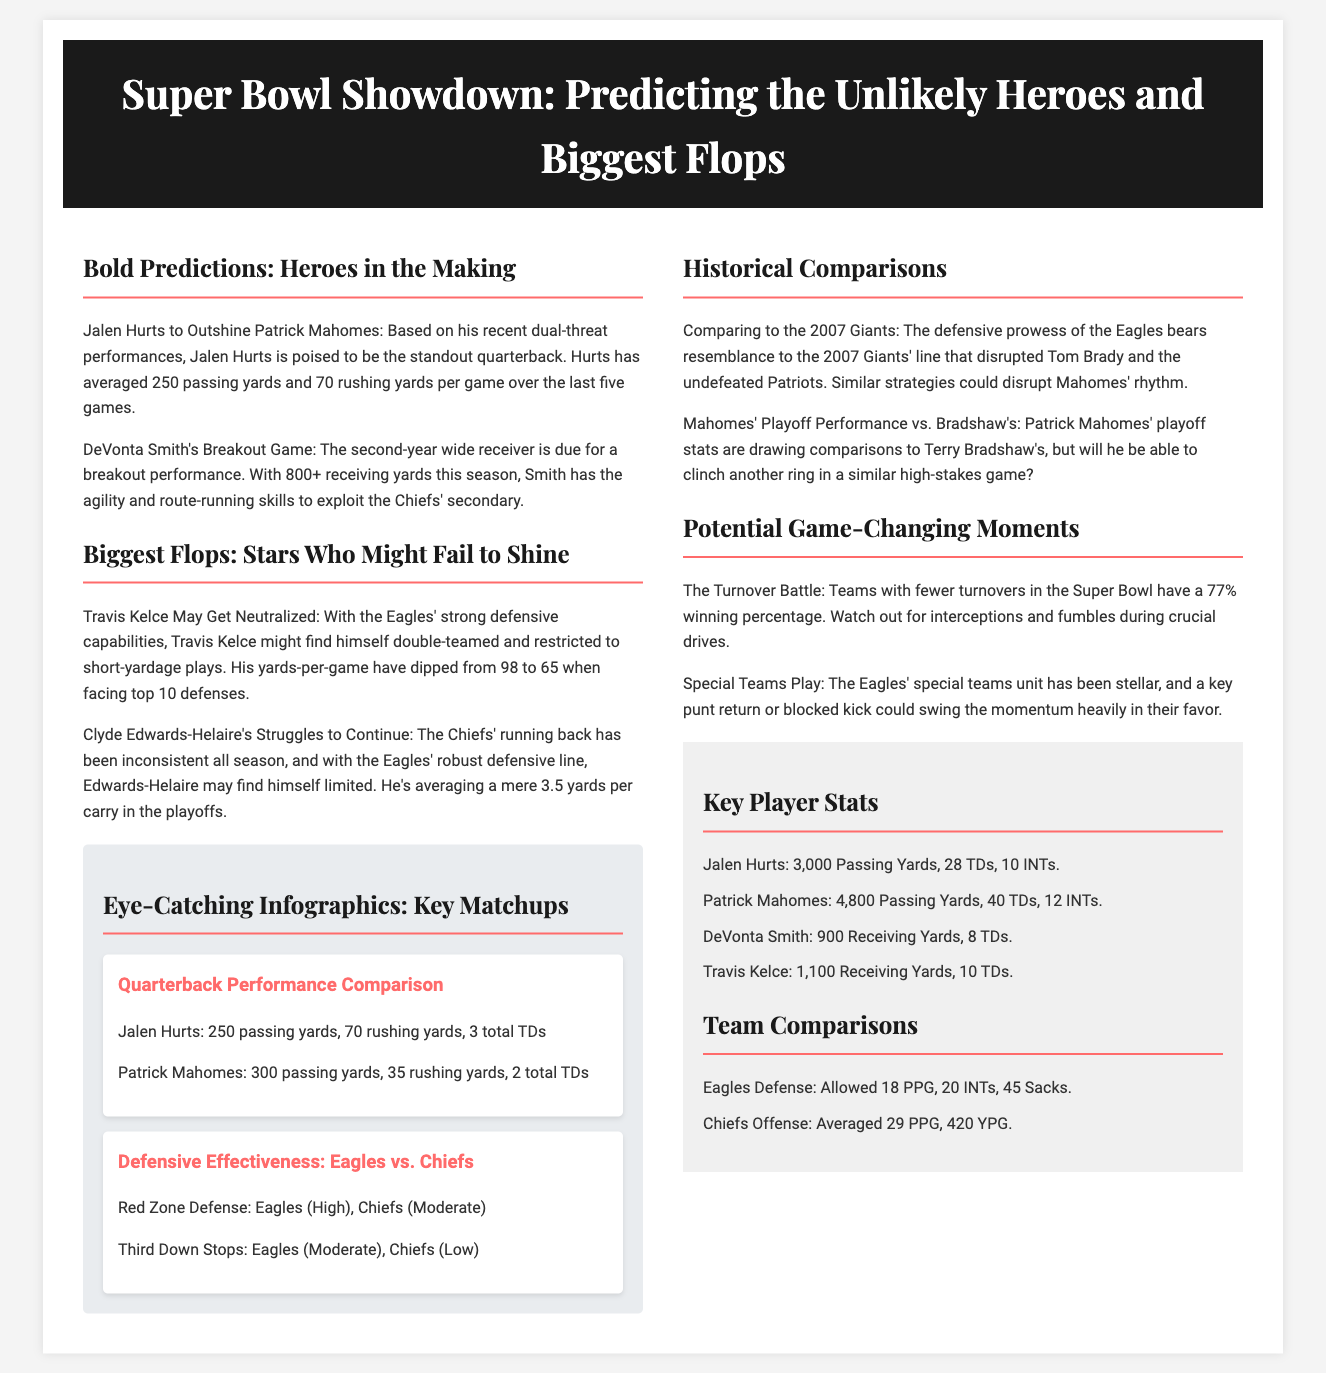What is the title of the article? The title of the article is prominently displayed at the top of the document.
Answer: Super Bowl Showdown: Predicting the Unlikely Heroes and Biggest Flops Who is predicted to outshine Patrick Mahomes? The prediction is made in the section discussing heroes, where Jalen Hurts is highlighted.
Answer: Jalen Hurts What is DeVonta Smith's receiving yard total this season? The document mentions that DeVonta Smith has 800+ receiving yards this season.
Answer: 800+ What is the average passing yards for Jalen Hurts over the last five games? This statistic is provided in the bold predictions section specifically about Jalen Hurts.
Answer: 250 passing yards What are the Eagles projected to allow in points per game? The document states that the Eagles' defense allowed 18 points per game.
Answer: 18 PPG How many touchdowns has Patrick Mahomes thrown this season? The key player stats section provides the total touchdowns for Patrick Mahomes.
Answer: 40 TDs Which player may be limited by the Eagles' robust defensive line? The document indicates that Clyde Edwards-Helaire may struggle against the Eagles' defense.
Answer: Clyde Edwards-Helaire What percentage of Super Bowl teams with fewer turnovers win? The document highlights a specific percentage regarding turnover and winning chances.
Answer: 77% How many total interceptions did the Eagles' defense achieve this season? The statistic for the Eagles' defensive interceptions is included in their team comparison.
Answer: 20 INTs 